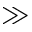<formula> <loc_0><loc_0><loc_500><loc_500>\gg</formula> 